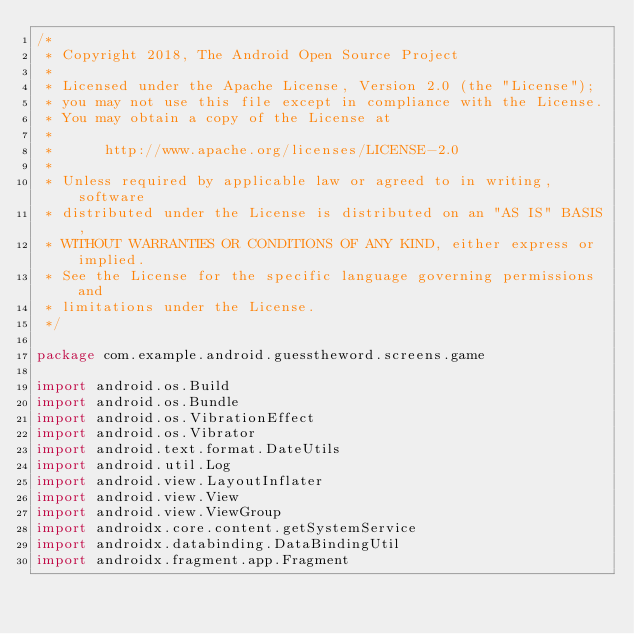<code> <loc_0><loc_0><loc_500><loc_500><_Kotlin_>/*
 * Copyright 2018, The Android Open Source Project
 *
 * Licensed under the Apache License, Version 2.0 (the "License");
 * you may not use this file except in compliance with the License.
 * You may obtain a copy of the License at
 *
 *      http://www.apache.org/licenses/LICENSE-2.0
 *
 * Unless required by applicable law or agreed to in writing, software
 * distributed under the License is distributed on an "AS IS" BASIS,
 * WITHOUT WARRANTIES OR CONDITIONS OF ANY KIND, either express or implied.
 * See the License for the specific language governing permissions and
 * limitations under the License.
 */

package com.example.android.guesstheword.screens.game

import android.os.Build
import android.os.Bundle
import android.os.VibrationEffect
import android.os.Vibrator
import android.text.format.DateUtils
import android.util.Log
import android.view.LayoutInflater
import android.view.View
import android.view.ViewGroup
import androidx.core.content.getSystemService
import androidx.databinding.DataBindingUtil
import androidx.fragment.app.Fragment</code> 